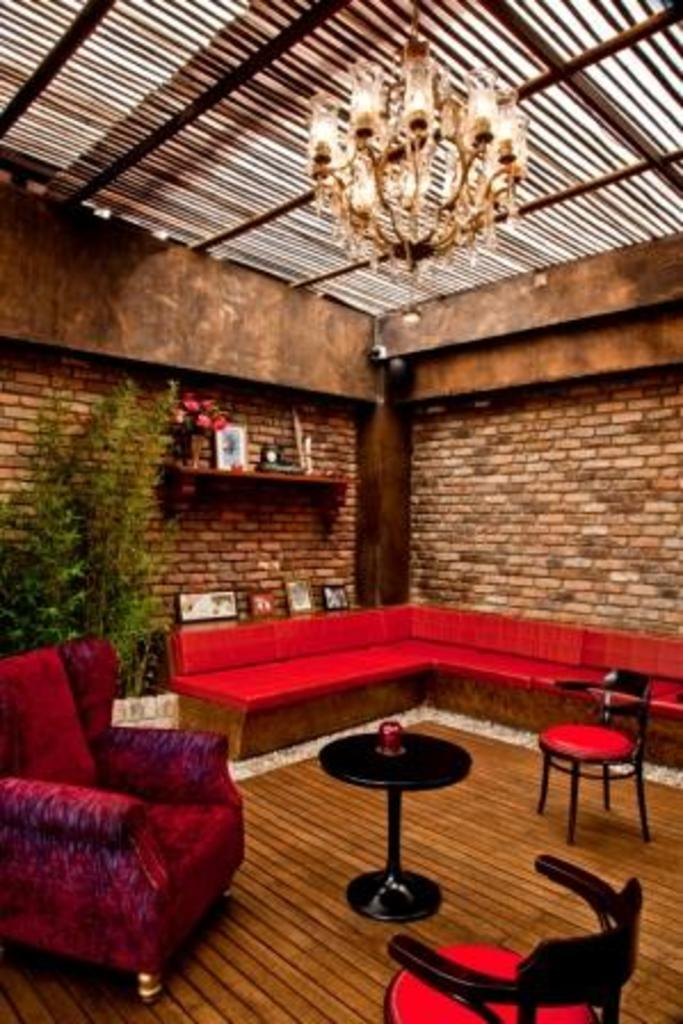What type of space is depicted in the image? There is a room in the image. What furniture is present in the room? There are chairs, a table, and a sofa in the room. What can be found on the wall in the room? There is a rack on the wall with a vase and a frame. What type of lighting is present in the room? There is a chandelier on the roof. Is there any vegetation visible in the image? Yes, there is a tree visible in the image. What type of advice is being given in the image? There is no indication of any advice being given in the image; it primarily features a room with various objects and furniture. 